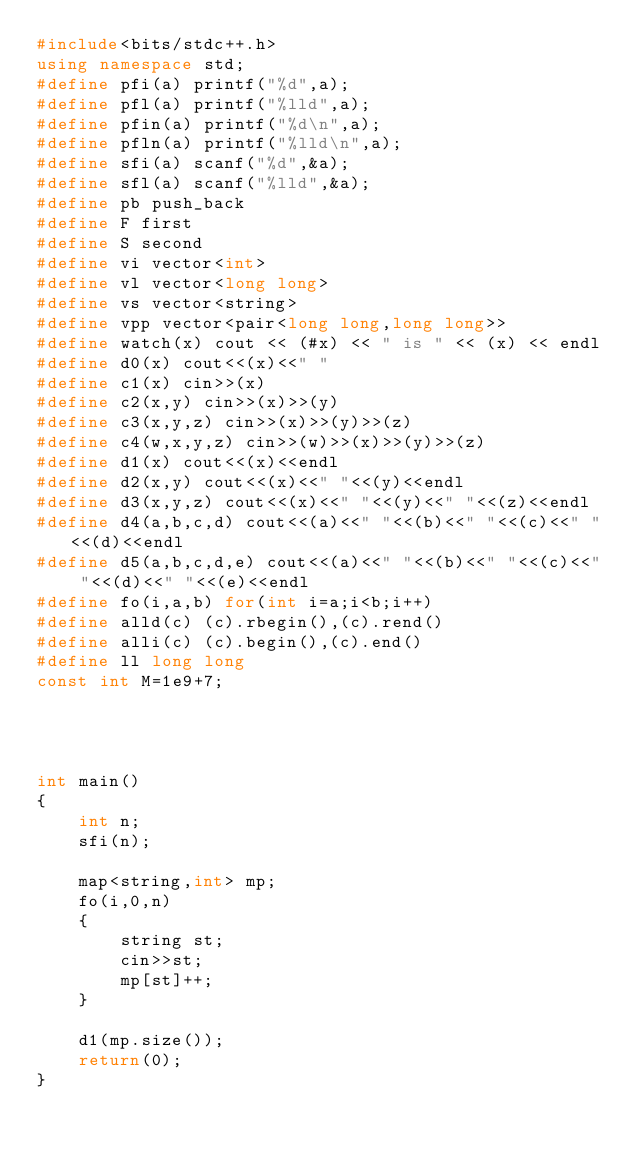<code> <loc_0><loc_0><loc_500><loc_500><_C++_>#include<bits/stdc++.h>
using namespace std;
#define pfi(a) printf("%d",a);
#define pfl(a) printf("%lld",a);
#define pfin(a) printf("%d\n",a);
#define pfln(a) printf("%lld\n",a);
#define sfi(a) scanf("%d",&a);
#define sfl(a) scanf("%lld",&a);
#define pb push_back
#define F first
#define S second
#define vi vector<int>
#define vl vector<long long>
#define vs vector<string>
#define vpp vector<pair<long long,long long>>
#define watch(x) cout << (#x) << " is " << (x) << endl
#define d0(x) cout<<(x)<<" "
#define c1(x) cin>>(x)
#define c2(x,y) cin>>(x)>>(y)
#define c3(x,y,z) cin>>(x)>>(y)>>(z)
#define c4(w,x,y,z) cin>>(w)>>(x)>>(y)>>(z)
#define d1(x) cout<<(x)<<endl
#define d2(x,y) cout<<(x)<<" "<<(y)<<endl
#define d3(x,y,z) cout<<(x)<<" "<<(y)<<" "<<(z)<<endl
#define d4(a,b,c,d) cout<<(a)<<" "<<(b)<<" "<<(c)<<" "<<(d)<<endl
#define d5(a,b,c,d,e) cout<<(a)<<" "<<(b)<<" "<<(c)<<" "<<(d)<<" "<<(e)<<endl
#define fo(i,a,b) for(int i=a;i<b;i++)
#define alld(c) (c).rbegin(),(c).rend()
#define alli(c) (c).begin(),(c).end()
#define ll long long
const int M=1e9+7;




int main() 
{ 
	int n;
	sfi(n);

	map<string,int> mp;
	fo(i,0,n)
	{
		string st;
		cin>>st;
		mp[st]++;
	}

	d1(mp.size());
	return(0);
}</code> 